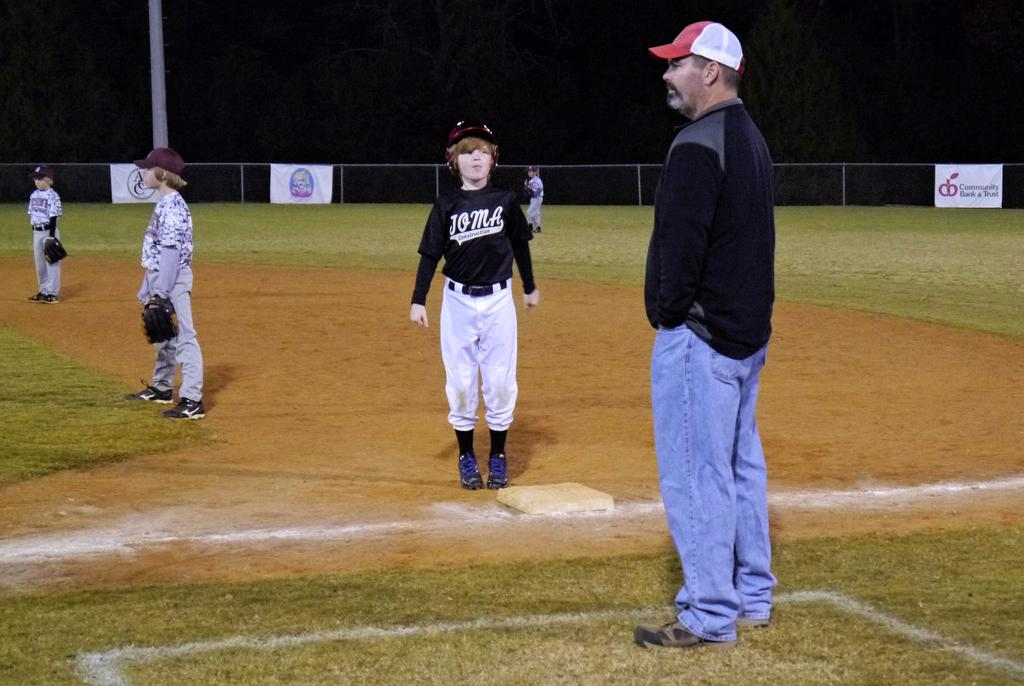<image>
Offer a succinct explanation of the picture presented. A team of little league baseball players for the Joma 